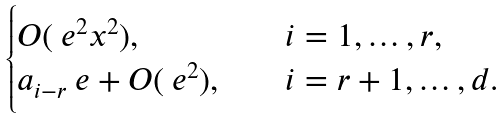Convert formula to latex. <formula><loc_0><loc_0><loc_500><loc_500>\begin{cases} O ( \ e ^ { 2 } x ^ { 2 } ) , & \quad i = 1 , \dots , r , \\ a _ { i - r } \ e + O ( \ e ^ { 2 } ) , & \quad i = r + 1 , \dots , d . \end{cases}</formula> 